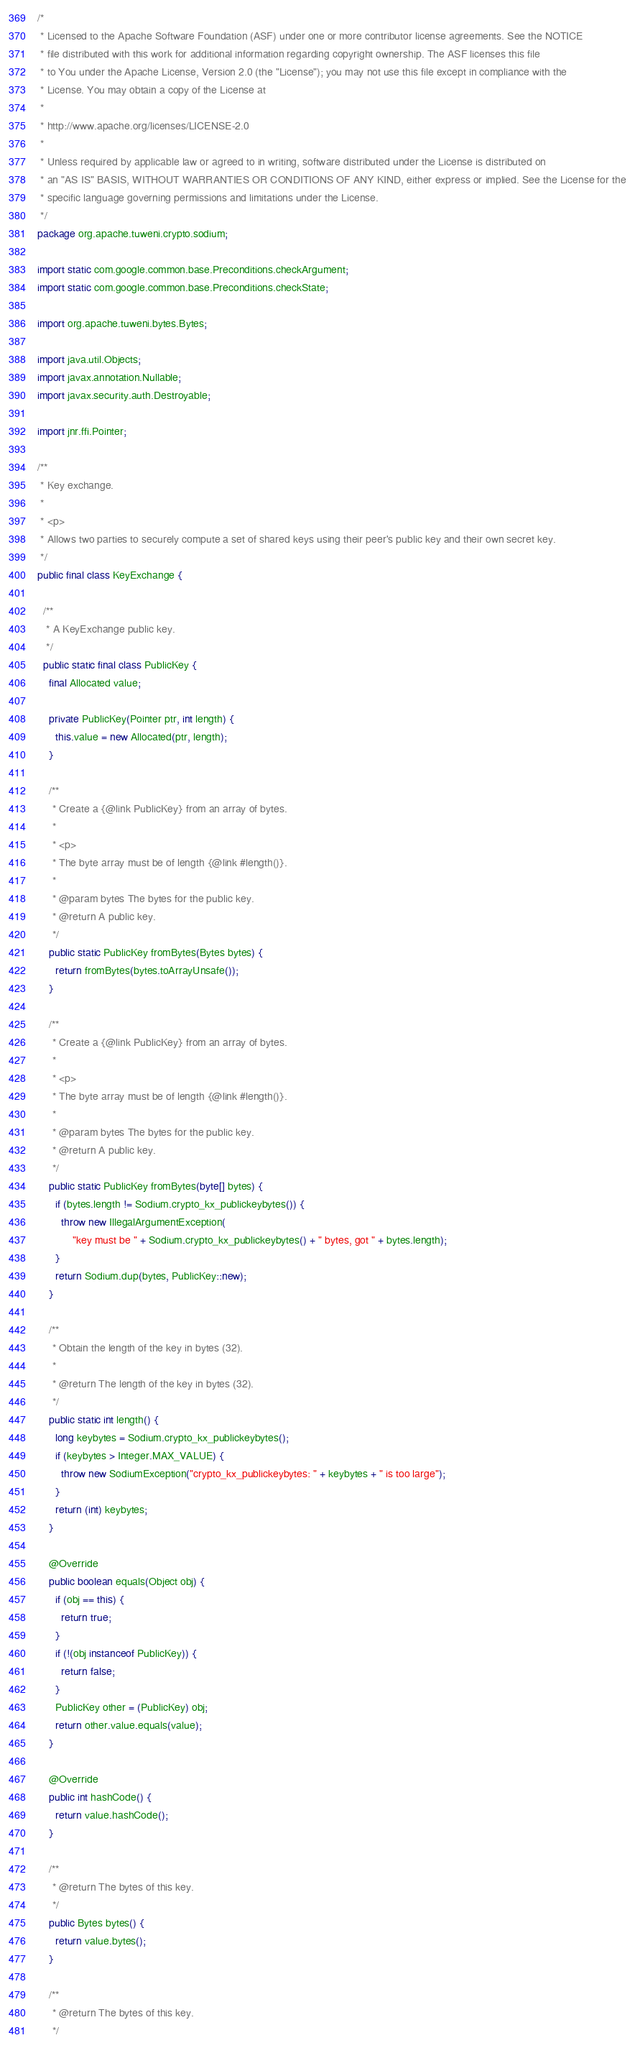<code> <loc_0><loc_0><loc_500><loc_500><_Java_>/*
 * Licensed to the Apache Software Foundation (ASF) under one or more contributor license agreements. See the NOTICE
 * file distributed with this work for additional information regarding copyright ownership. The ASF licenses this file
 * to You under the Apache License, Version 2.0 (the "License"); you may not use this file except in compliance with the
 * License. You may obtain a copy of the License at
 *
 * http://www.apache.org/licenses/LICENSE-2.0
 *
 * Unless required by applicable law or agreed to in writing, software distributed under the License is distributed on
 * an "AS IS" BASIS, WITHOUT WARRANTIES OR CONDITIONS OF ANY KIND, either express or implied. See the License for the
 * specific language governing permissions and limitations under the License.
 */
package org.apache.tuweni.crypto.sodium;

import static com.google.common.base.Preconditions.checkArgument;
import static com.google.common.base.Preconditions.checkState;

import org.apache.tuweni.bytes.Bytes;

import java.util.Objects;
import javax.annotation.Nullable;
import javax.security.auth.Destroyable;

import jnr.ffi.Pointer;

/**
 * Key exchange.
 *
 * <p>
 * Allows two parties to securely compute a set of shared keys using their peer's public key and their own secret key.
 */
public final class KeyExchange {

  /**
   * A KeyExchange public key.
   */
  public static final class PublicKey {
    final Allocated value;

    private PublicKey(Pointer ptr, int length) {
      this.value = new Allocated(ptr, length);
    }

    /**
     * Create a {@link PublicKey} from an array of bytes.
     *
     * <p>
     * The byte array must be of length {@link #length()}.
     *
     * @param bytes The bytes for the public key.
     * @return A public key.
     */
    public static PublicKey fromBytes(Bytes bytes) {
      return fromBytes(bytes.toArrayUnsafe());
    }

    /**
     * Create a {@link PublicKey} from an array of bytes.
     *
     * <p>
     * The byte array must be of length {@link #length()}.
     *
     * @param bytes The bytes for the public key.
     * @return A public key.
     */
    public static PublicKey fromBytes(byte[] bytes) {
      if (bytes.length != Sodium.crypto_kx_publickeybytes()) {
        throw new IllegalArgumentException(
            "key must be " + Sodium.crypto_kx_publickeybytes() + " bytes, got " + bytes.length);
      }
      return Sodium.dup(bytes, PublicKey::new);
    }

    /**
     * Obtain the length of the key in bytes (32).
     *
     * @return The length of the key in bytes (32).
     */
    public static int length() {
      long keybytes = Sodium.crypto_kx_publickeybytes();
      if (keybytes > Integer.MAX_VALUE) {
        throw new SodiumException("crypto_kx_publickeybytes: " + keybytes + " is too large");
      }
      return (int) keybytes;
    }

    @Override
    public boolean equals(Object obj) {
      if (obj == this) {
        return true;
      }
      if (!(obj instanceof PublicKey)) {
        return false;
      }
      PublicKey other = (PublicKey) obj;
      return other.value.equals(value);
    }

    @Override
    public int hashCode() {
      return value.hashCode();
    }

    /**
     * @return The bytes of this key.
     */
    public Bytes bytes() {
      return value.bytes();
    }

    /**
     * @return The bytes of this key.
     */</code> 